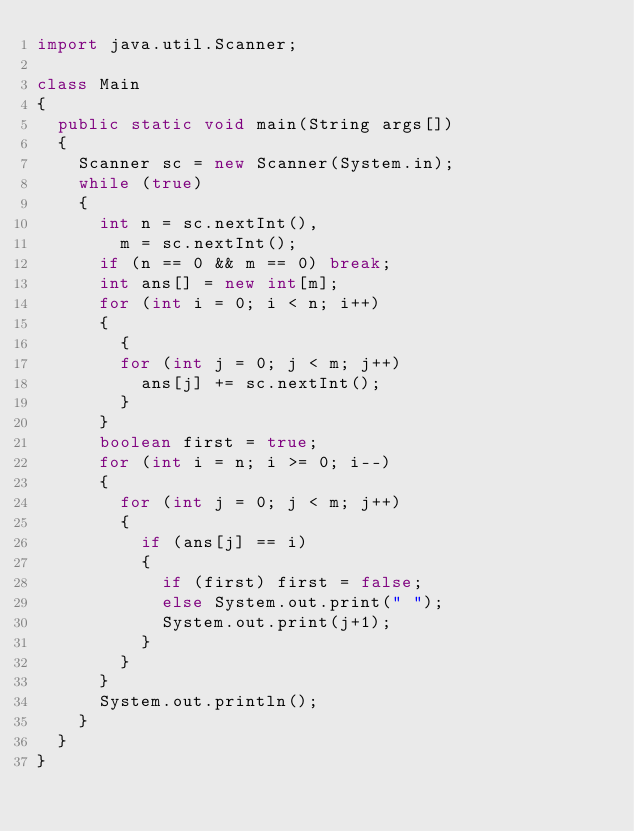Convert code to text. <code><loc_0><loc_0><loc_500><loc_500><_Java_>import java.util.Scanner;

class Main
{
	public static void main(String args[])
	{
		Scanner sc = new Scanner(System.in);
		while (true)
		{
			int n = sc.nextInt(),
				m = sc.nextInt();
			if (n == 0 && m == 0) break;
			int ans[] = new int[m];
			for (int i = 0; i < n; i++)
			{
				{
				for (int j = 0; j < m; j++)
					ans[j] += sc.nextInt();
				}
			}
			boolean first = true;
			for (int i = n; i >= 0; i--)
			{
				for (int j = 0; j < m; j++)
				{
					if (ans[j] == i)
					{
						if (first) first = false;
						else System.out.print(" ");
						System.out.print(j+1);
					}
				}
			}
			System.out.println();
		}
	}
}</code> 